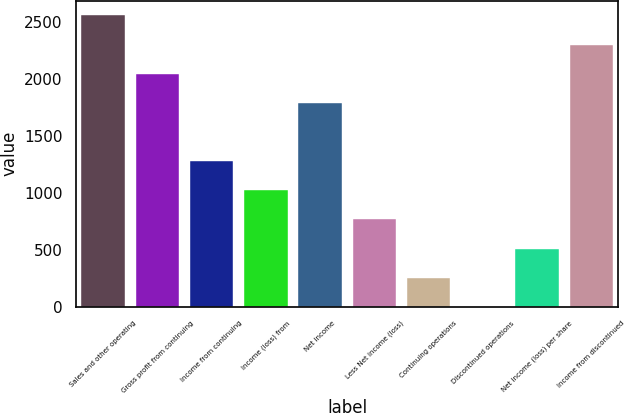<chart> <loc_0><loc_0><loc_500><loc_500><bar_chart><fcel>Sales and other operating<fcel>Gross profit from continuing<fcel>Income from continuing<fcel>Income (loss) from<fcel>Net income<fcel>Less Net income (loss)<fcel>Continuing operations<fcel>Discontinued operations<fcel>Net income (loss) per share<fcel>Income from discontinued<nl><fcel>2557.01<fcel>2045.61<fcel>1278.51<fcel>1022.81<fcel>1789.91<fcel>767.11<fcel>255.71<fcel>0.01<fcel>511.41<fcel>2301.31<nl></chart> 